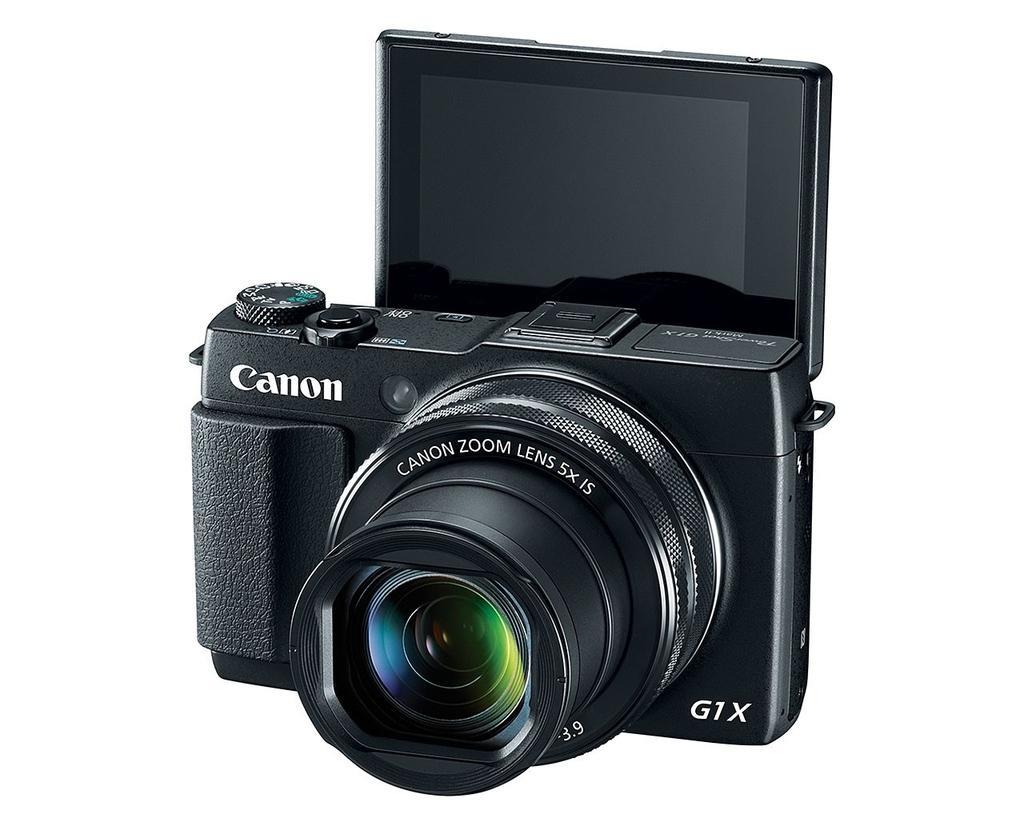Describe this image in one or two sentences. There is a black camera with something written on that. In the background it is white. Also there is a screen for the camera. 